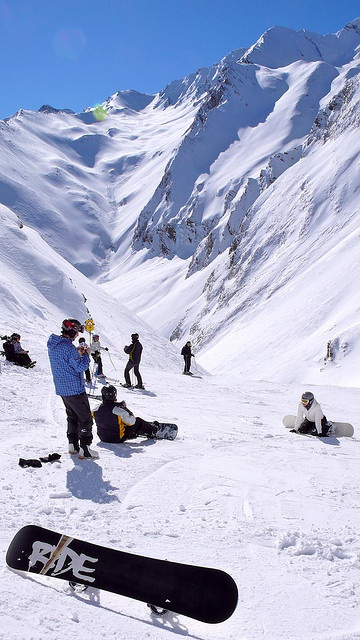Describe the objects in this image and their specific colors. I can see snowboard in gray, black, darkgray, and lavender tones, people in gray, black, blue, and navy tones, people in gray, black, darkgray, and white tones, people in gray, black, darkgray, and lightgray tones, and snowboard in gray, black, and lightgray tones in this image. 